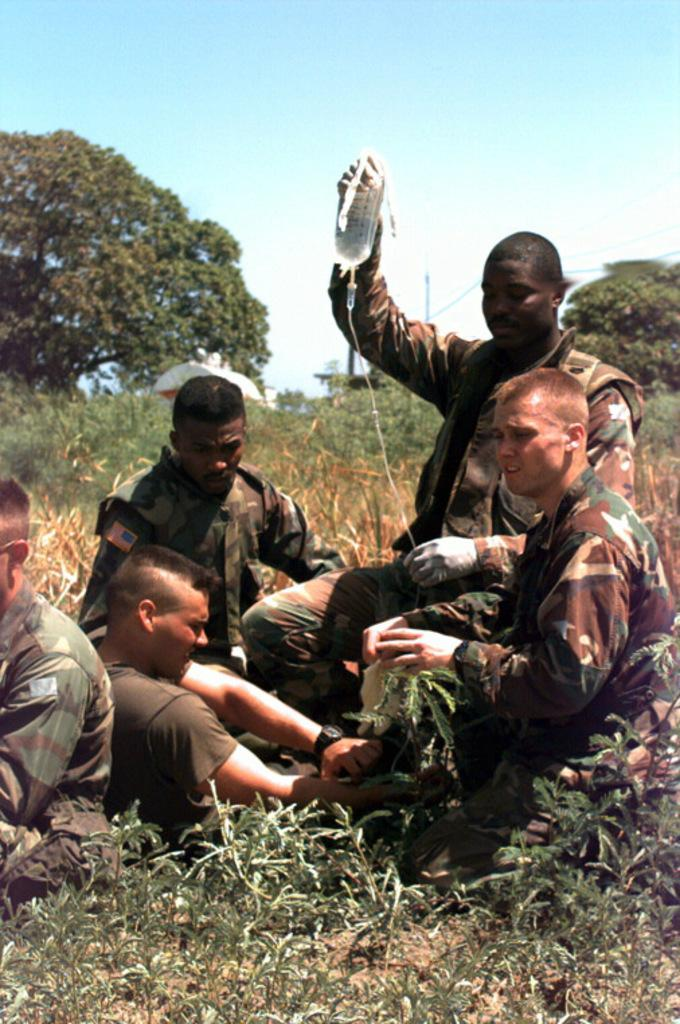What are the people in the image doing? There is a group of people sitting in the image. What can be seen at the bottom of the image? There are plants at the bottom of the image. What is visible in the background of the image? There are trees and the sky visible in the background of the image. How many letters are in the mailbox in the image? There is no mailbox present in the image. How many girls are in the image? The provided facts do not mention the gender of the people in the image, so we cannot determine the number of girls. 